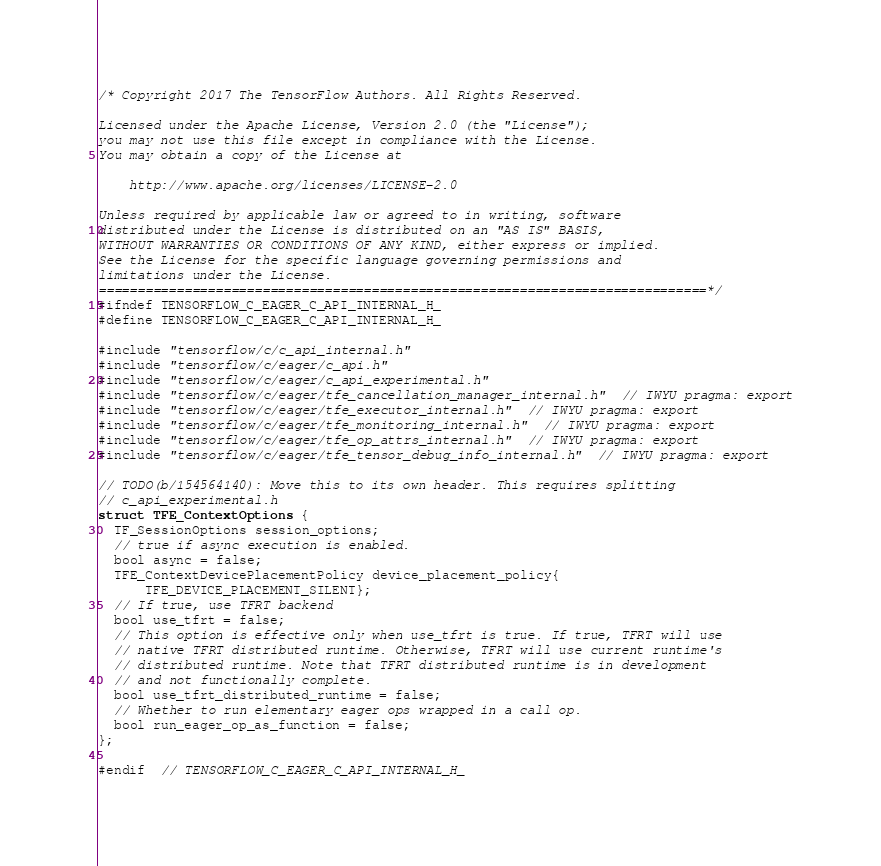Convert code to text. <code><loc_0><loc_0><loc_500><loc_500><_C_>/* Copyright 2017 The TensorFlow Authors. All Rights Reserved.

Licensed under the Apache License, Version 2.0 (the "License");
you may not use this file except in compliance with the License.
You may obtain a copy of the License at

    http://www.apache.org/licenses/LICENSE-2.0

Unless required by applicable law or agreed to in writing, software
distributed under the License is distributed on an "AS IS" BASIS,
WITHOUT WARRANTIES OR CONDITIONS OF ANY KIND, either express or implied.
See the License for the specific language governing permissions and
limitations under the License.
==============================================================================*/
#ifndef TENSORFLOW_C_EAGER_C_API_INTERNAL_H_
#define TENSORFLOW_C_EAGER_C_API_INTERNAL_H_

#include "tensorflow/c/c_api_internal.h"
#include "tensorflow/c/eager/c_api.h"
#include "tensorflow/c/eager/c_api_experimental.h"
#include "tensorflow/c/eager/tfe_cancellation_manager_internal.h"  // IWYU pragma: export
#include "tensorflow/c/eager/tfe_executor_internal.h"  // IWYU pragma: export
#include "tensorflow/c/eager/tfe_monitoring_internal.h"  // IWYU pragma: export
#include "tensorflow/c/eager/tfe_op_attrs_internal.h"  // IWYU pragma: export
#include "tensorflow/c/eager/tfe_tensor_debug_info_internal.h"  // IWYU pragma: export

// TODO(b/154564140): Move this to its own header. This requires splitting
// c_api_experimental.h
struct TFE_ContextOptions {
  TF_SessionOptions session_options;
  // true if async execution is enabled.
  bool async = false;
  TFE_ContextDevicePlacementPolicy device_placement_policy{
      TFE_DEVICE_PLACEMENT_SILENT};
  // If true, use TFRT backend
  bool use_tfrt = false;
  // This option is effective only when use_tfrt is true. If true, TFRT will use
  // native TFRT distributed runtime. Otherwise, TFRT will use current runtime's
  // distributed runtime. Note that TFRT distributed runtime is in development
  // and not functionally complete.
  bool use_tfrt_distributed_runtime = false;
  // Whether to run elementary eager ops wrapped in a call op.
  bool run_eager_op_as_function = false;
};

#endif  // TENSORFLOW_C_EAGER_C_API_INTERNAL_H_
</code> 